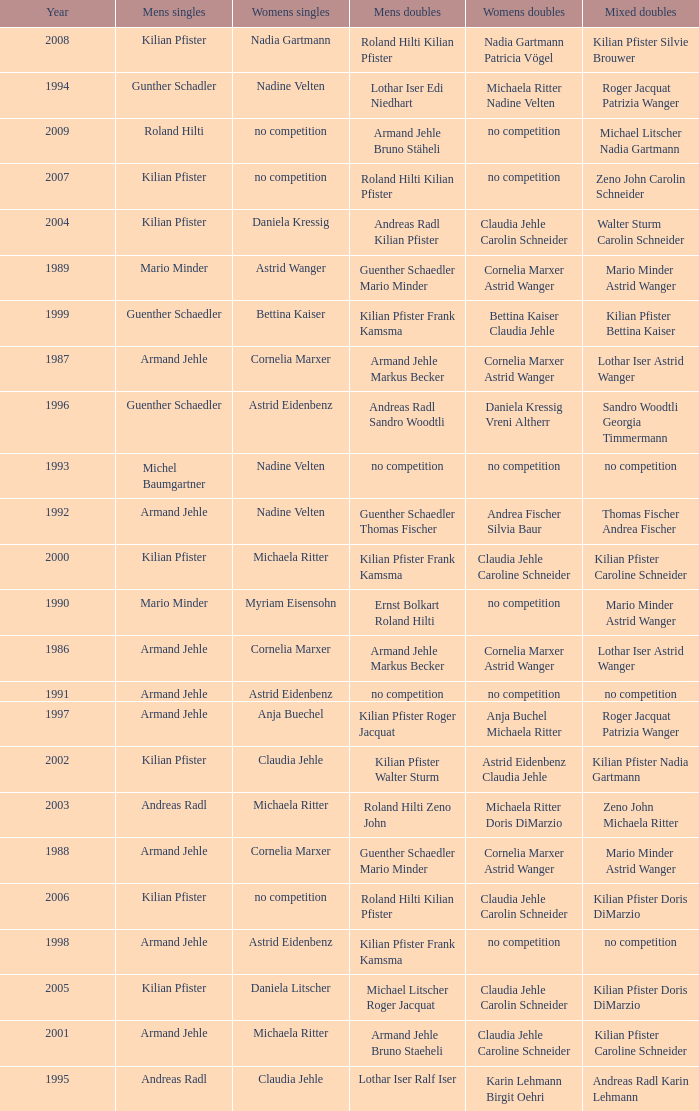What is the most current year where the women's doubles champions are astrid eidenbenz claudia jehle 2002.0. 